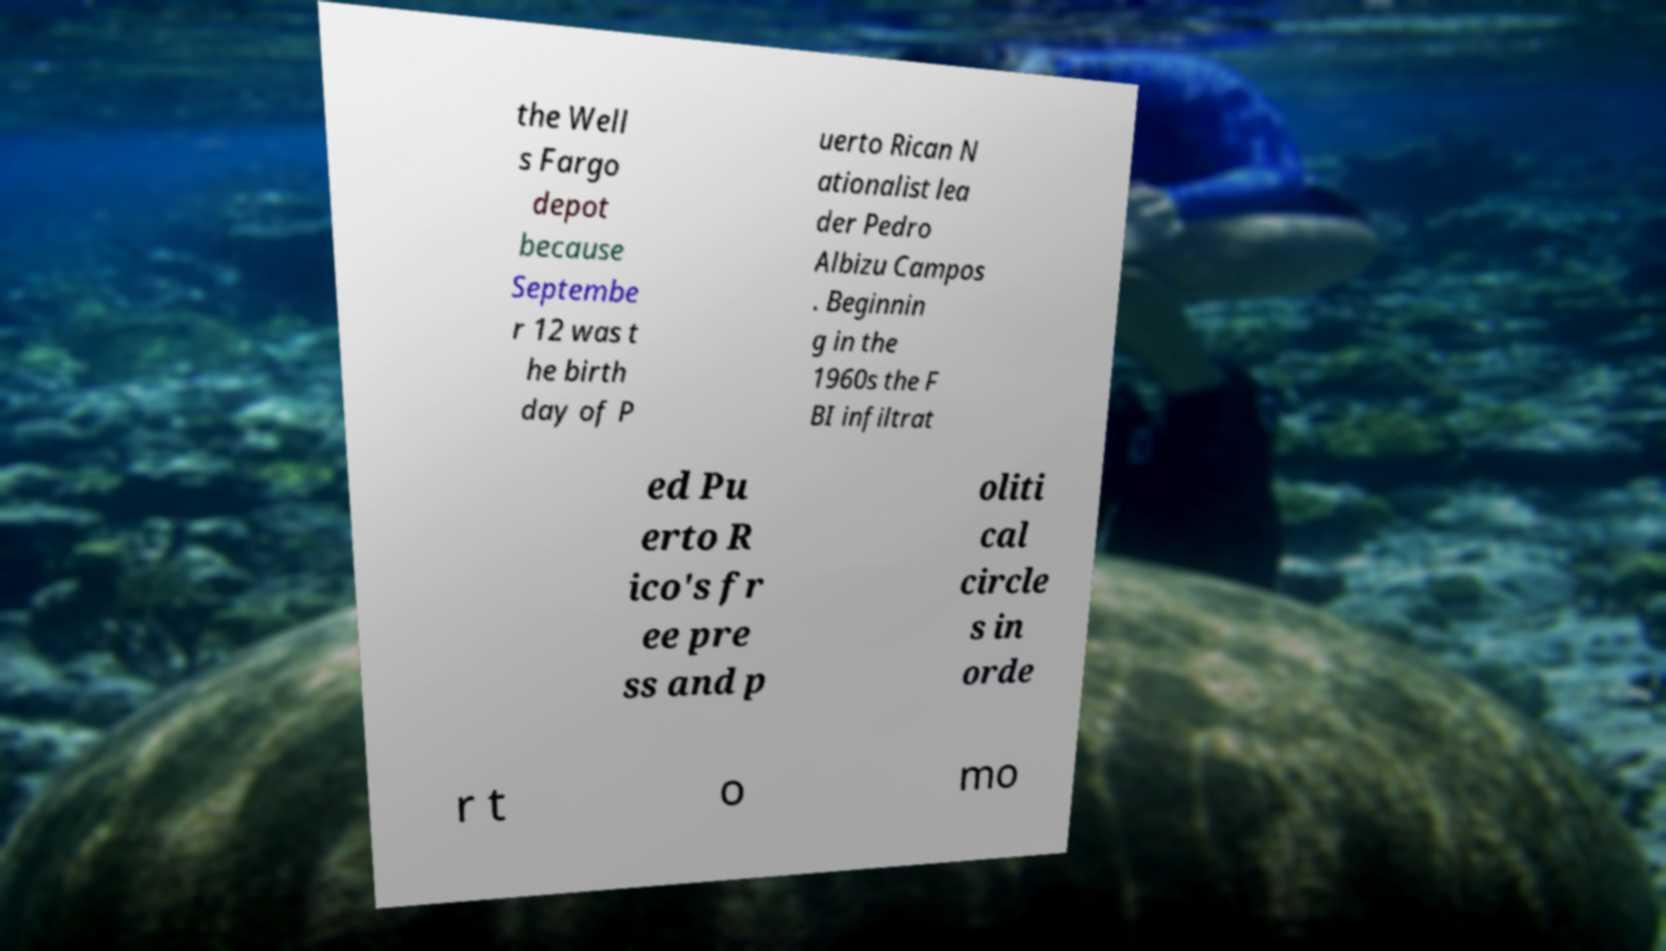I need the written content from this picture converted into text. Can you do that? the Well s Fargo depot because Septembe r 12 was t he birth day of P uerto Rican N ationalist lea der Pedro Albizu Campos . Beginnin g in the 1960s the F BI infiltrat ed Pu erto R ico's fr ee pre ss and p oliti cal circle s in orde r t o mo 